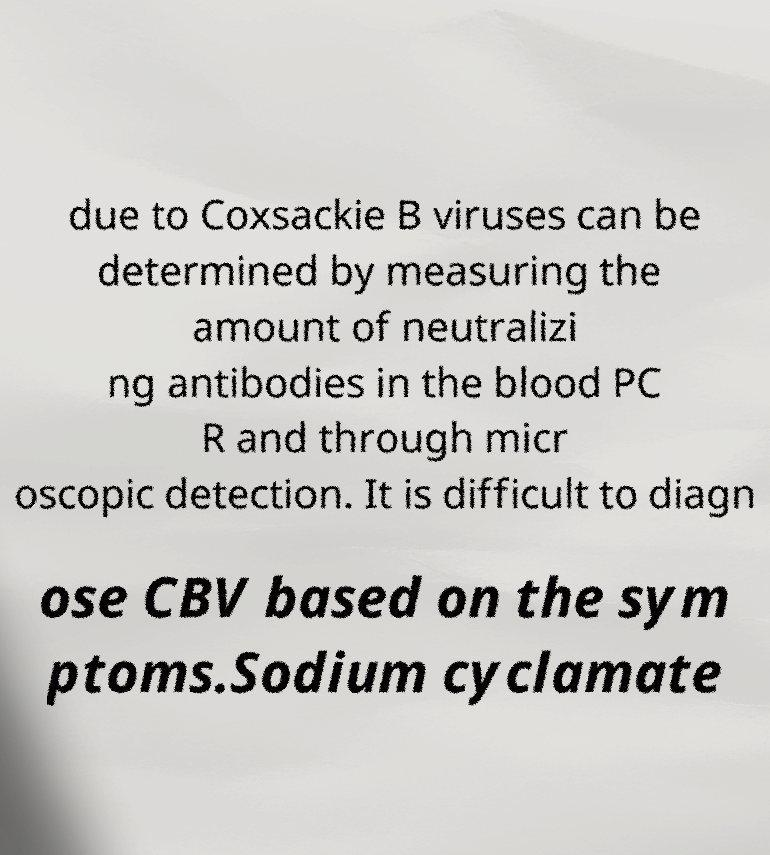Please read and relay the text visible in this image. What does it say? due to Coxsackie B viruses can be determined by measuring the amount of neutralizi ng antibodies in the blood PC R and through micr oscopic detection. It is difficult to diagn ose CBV based on the sym ptoms.Sodium cyclamate 